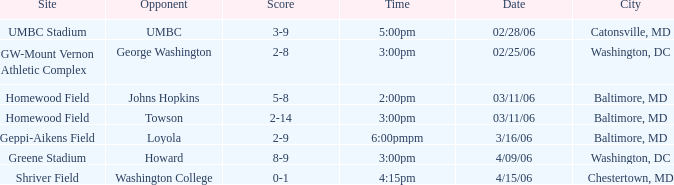Who was the Opponent at Homewood Field with a Score of 5-8? Johns Hopkins. 